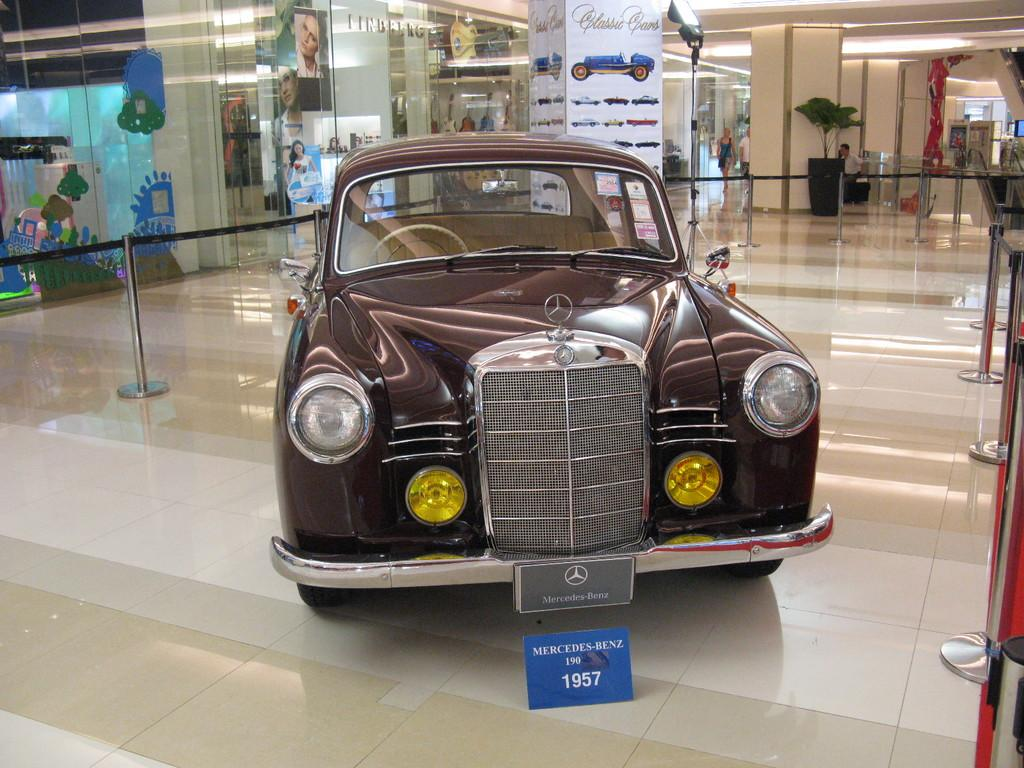What is placed on the floor in the image? There is a car on the floor in the image. What can be seen in the image besides the car? There is a rope, pole barriers, a light on a stand, plants, posters on glasses, objects on the ceiling, and lights on the ceiling in the image. What type of zinc is present on the island in the image? There is no zinc or island present in the image. What is the answer to the question that is not asked in the image? The image does not contain any questions or answers, so it is not possible to determine the answer to a question that is not asked. 